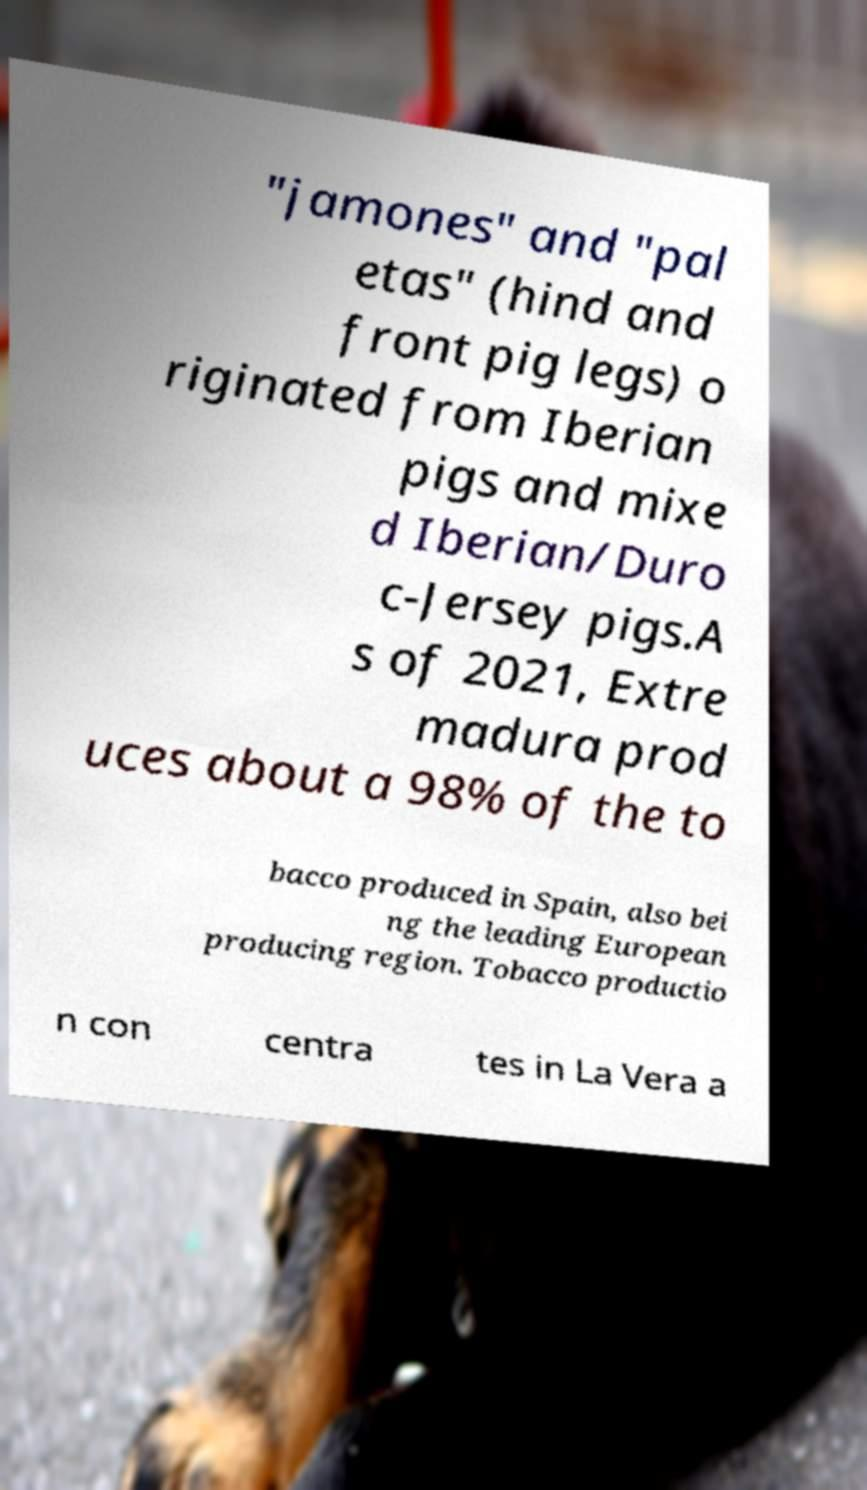What messages or text are displayed in this image? I need them in a readable, typed format. "jamones" and "pal etas" (hind and front pig legs) o riginated from Iberian pigs and mixe d Iberian/Duro c-Jersey pigs.A s of 2021, Extre madura prod uces about a 98% of the to bacco produced in Spain, also bei ng the leading European producing region. Tobacco productio n con centra tes in La Vera a 